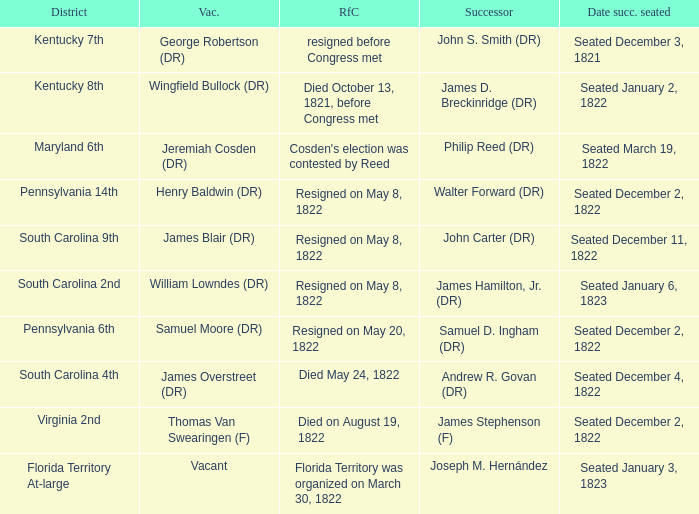Can you parse all the data within this table? {'header': ['District', 'Vac.', 'RfC', 'Successor', 'Date succ. seated'], 'rows': [['Kentucky 7th', 'George Robertson (DR)', 'resigned before Congress met', 'John S. Smith (DR)', 'Seated December 3, 1821'], ['Kentucky 8th', 'Wingfield Bullock (DR)', 'Died October 13, 1821, before Congress met', 'James D. Breckinridge (DR)', 'Seated January 2, 1822'], ['Maryland 6th', 'Jeremiah Cosden (DR)', "Cosden's election was contested by Reed", 'Philip Reed (DR)', 'Seated March 19, 1822'], ['Pennsylvania 14th', 'Henry Baldwin (DR)', 'Resigned on May 8, 1822', 'Walter Forward (DR)', 'Seated December 2, 1822'], ['South Carolina 9th', 'James Blair (DR)', 'Resigned on May 8, 1822', 'John Carter (DR)', 'Seated December 11, 1822'], ['South Carolina 2nd', 'William Lowndes (DR)', 'Resigned on May 8, 1822', 'James Hamilton, Jr. (DR)', 'Seated January 6, 1823'], ['Pennsylvania 6th', 'Samuel Moore (DR)', 'Resigned on May 20, 1822', 'Samuel D. Ingham (DR)', 'Seated December 2, 1822'], ['South Carolina 4th', 'James Overstreet (DR)', 'Died May 24, 1822', 'Andrew R. Govan (DR)', 'Seated December 4, 1822'], ['Virginia 2nd', 'Thomas Van Swearingen (F)', 'Died on August 19, 1822', 'James Stephenson (F)', 'Seated December 2, 1822'], ['Florida Territory At-large', 'Vacant', 'Florida Territory was organized on March 30, 1822', 'Joseph M. Hernández', 'Seated January 3, 1823']]} What is the reason for change when maryland 6th is the district?  Cosden's election was contested by Reed. 